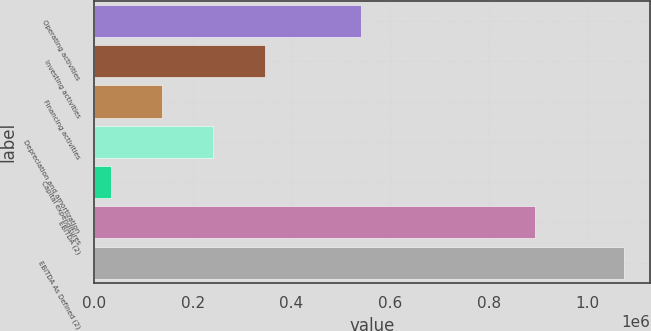Convert chart. <chart><loc_0><loc_0><loc_500><loc_500><bar_chart><fcel>Operating activities<fcel>Investing activities<fcel>Financing activities<fcel>Depreciation and amortization<fcel>Capital expenditures<fcel>EBITDA (2)<fcel>EBITDA As Defined (2)<nl><fcel>541222<fcel>345864<fcel>138052<fcel>241958<fcel>34146<fcel>892583<fcel>1.07321e+06<nl></chart> 